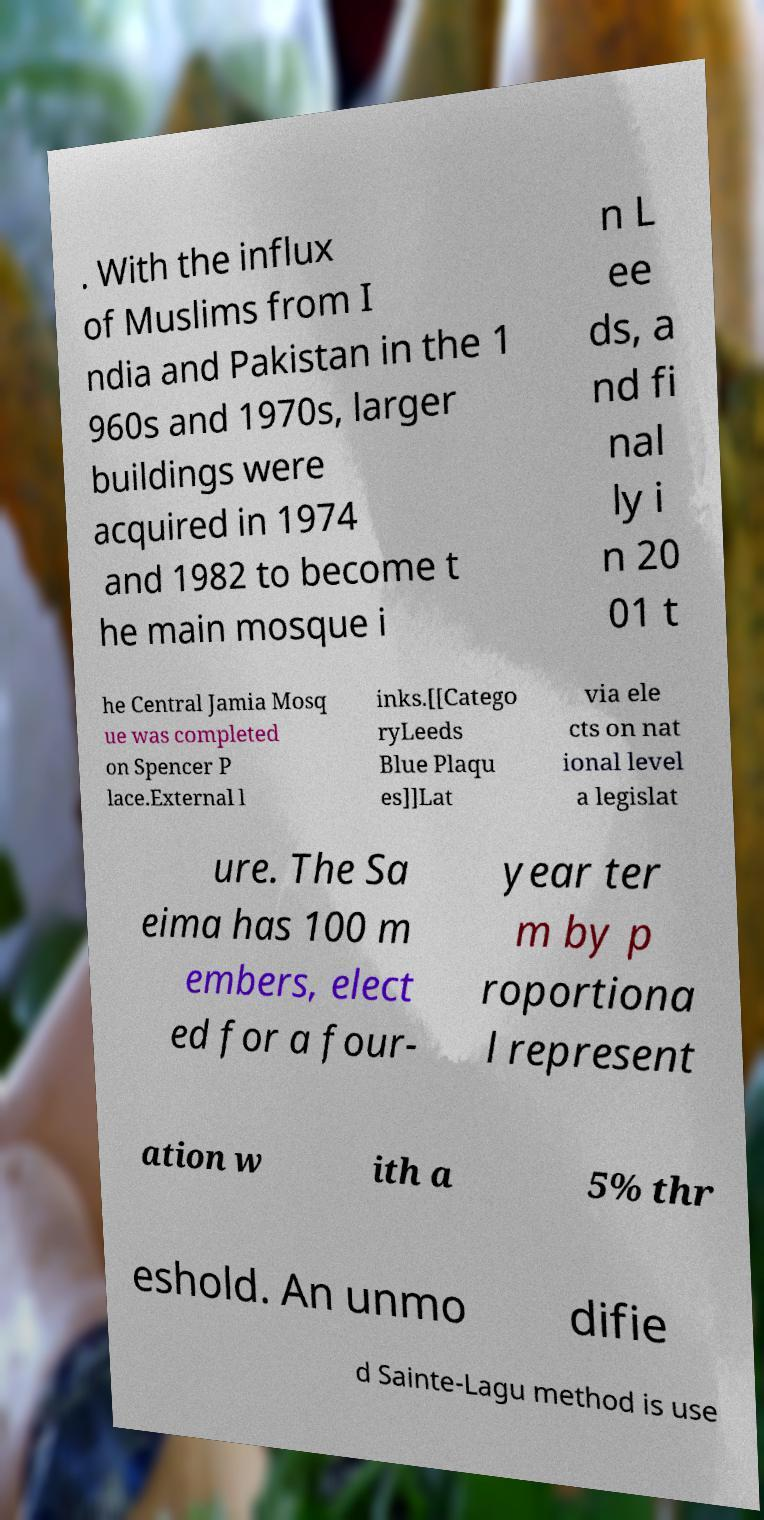Can you accurately transcribe the text from the provided image for me? . With the influx of Muslims from I ndia and Pakistan in the 1 960s and 1970s, larger buildings were acquired in 1974 and 1982 to become t he main mosque i n L ee ds, a nd fi nal ly i n 20 01 t he Central Jamia Mosq ue was completed on Spencer P lace.External l inks.[[Catego ryLeeds Blue Plaqu es]]Lat via ele cts on nat ional level a legislat ure. The Sa eima has 100 m embers, elect ed for a four- year ter m by p roportiona l represent ation w ith a 5% thr eshold. An unmo difie d Sainte-Lagu method is use 